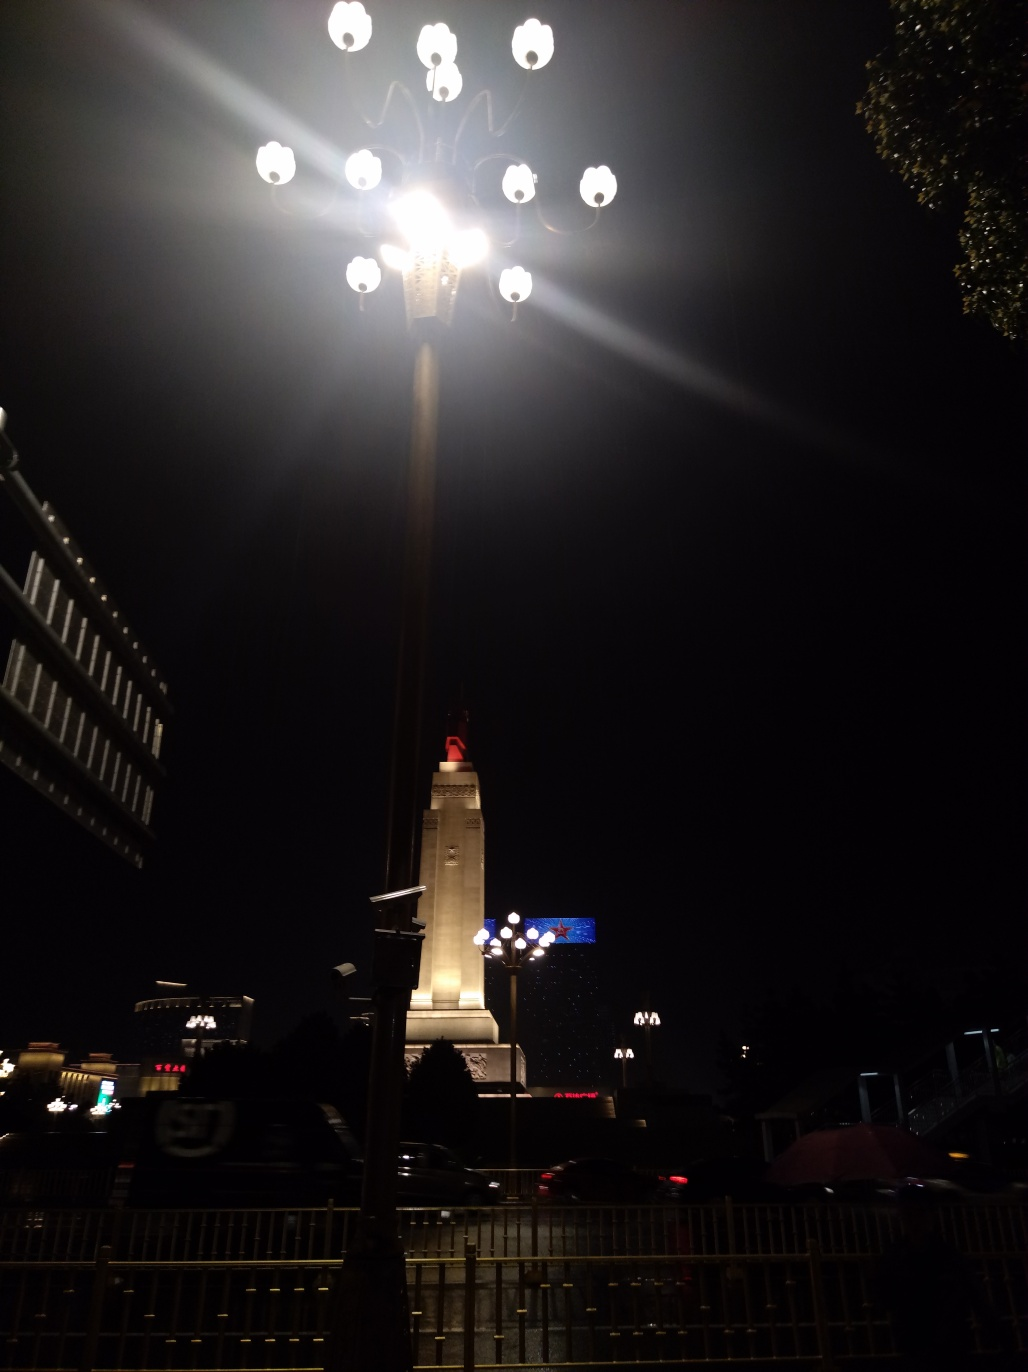Are there any focus issues in this image? Upon a thorough review, the image seems mostly in focus, although due to the bright lighting coming from the lamp post, certain areas may appear overexposed which could lead one to believe there's a focus issue. However, the majority of the image, including the structures and the surroundings, are discernible with decent clarity. Thus, the most accurate assessment would be that there are no significant focus issues affecting the overall visibility or understanding of the scene depicted in this image. 